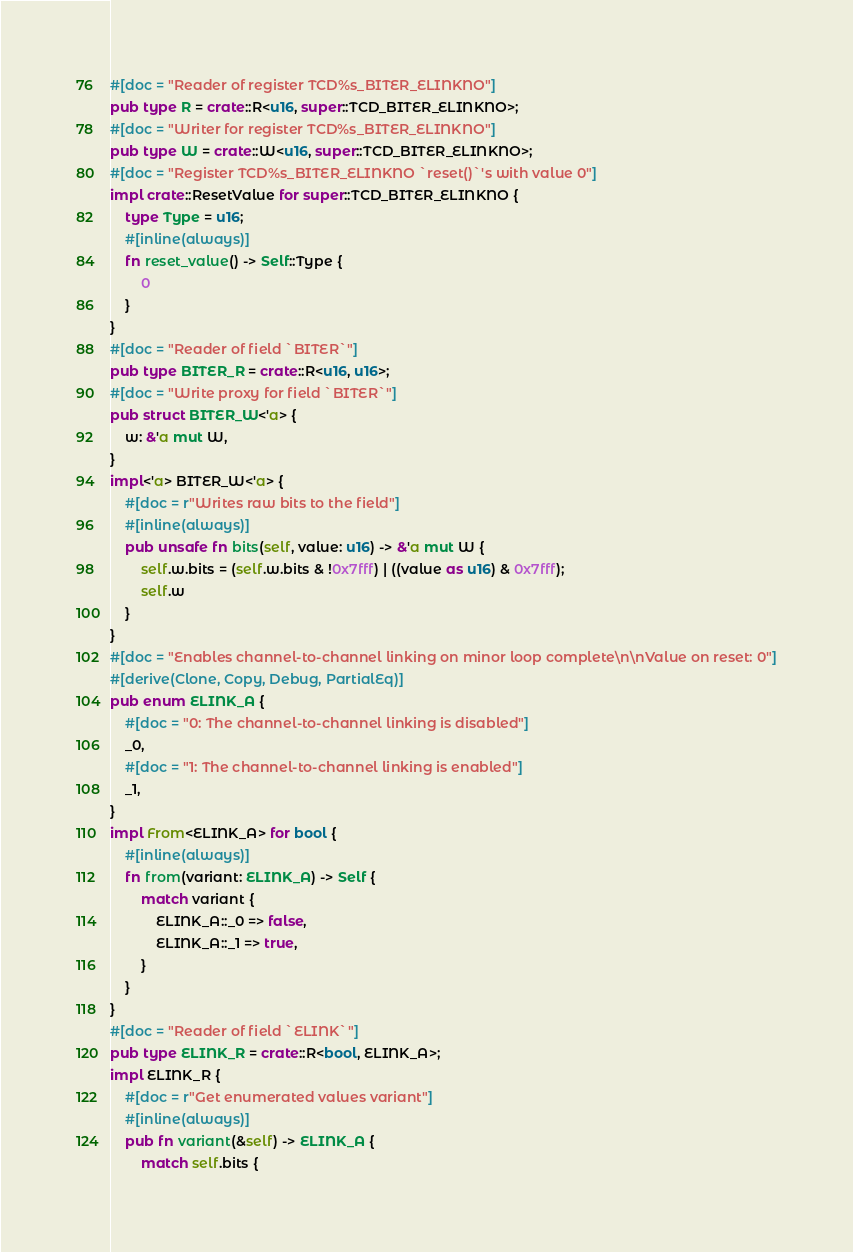Convert code to text. <code><loc_0><loc_0><loc_500><loc_500><_Rust_>#[doc = "Reader of register TCD%s_BITER_ELINKNO"]
pub type R = crate::R<u16, super::TCD_BITER_ELINKNO>;
#[doc = "Writer for register TCD%s_BITER_ELINKNO"]
pub type W = crate::W<u16, super::TCD_BITER_ELINKNO>;
#[doc = "Register TCD%s_BITER_ELINKNO `reset()`'s with value 0"]
impl crate::ResetValue for super::TCD_BITER_ELINKNO {
    type Type = u16;
    #[inline(always)]
    fn reset_value() -> Self::Type {
        0
    }
}
#[doc = "Reader of field `BITER`"]
pub type BITER_R = crate::R<u16, u16>;
#[doc = "Write proxy for field `BITER`"]
pub struct BITER_W<'a> {
    w: &'a mut W,
}
impl<'a> BITER_W<'a> {
    #[doc = r"Writes raw bits to the field"]
    #[inline(always)]
    pub unsafe fn bits(self, value: u16) -> &'a mut W {
        self.w.bits = (self.w.bits & !0x7fff) | ((value as u16) & 0x7fff);
        self.w
    }
}
#[doc = "Enables channel-to-channel linking on minor loop complete\n\nValue on reset: 0"]
#[derive(Clone, Copy, Debug, PartialEq)]
pub enum ELINK_A {
    #[doc = "0: The channel-to-channel linking is disabled"]
    _0,
    #[doc = "1: The channel-to-channel linking is enabled"]
    _1,
}
impl From<ELINK_A> for bool {
    #[inline(always)]
    fn from(variant: ELINK_A) -> Self {
        match variant {
            ELINK_A::_0 => false,
            ELINK_A::_1 => true,
        }
    }
}
#[doc = "Reader of field `ELINK`"]
pub type ELINK_R = crate::R<bool, ELINK_A>;
impl ELINK_R {
    #[doc = r"Get enumerated values variant"]
    #[inline(always)]
    pub fn variant(&self) -> ELINK_A {
        match self.bits {</code> 